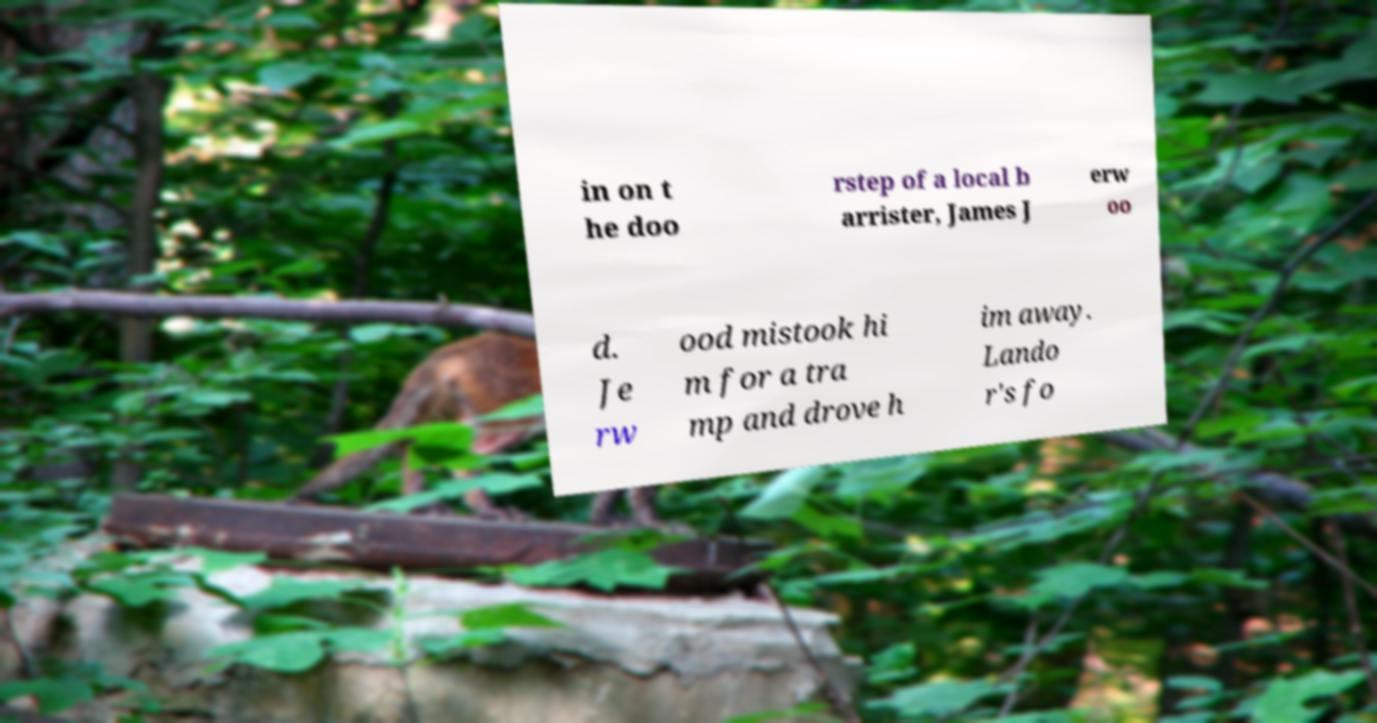For documentation purposes, I need the text within this image transcribed. Could you provide that? in on t he doo rstep of a local b arrister, James J erw oo d. Je rw ood mistook hi m for a tra mp and drove h im away. Lando r's fo 